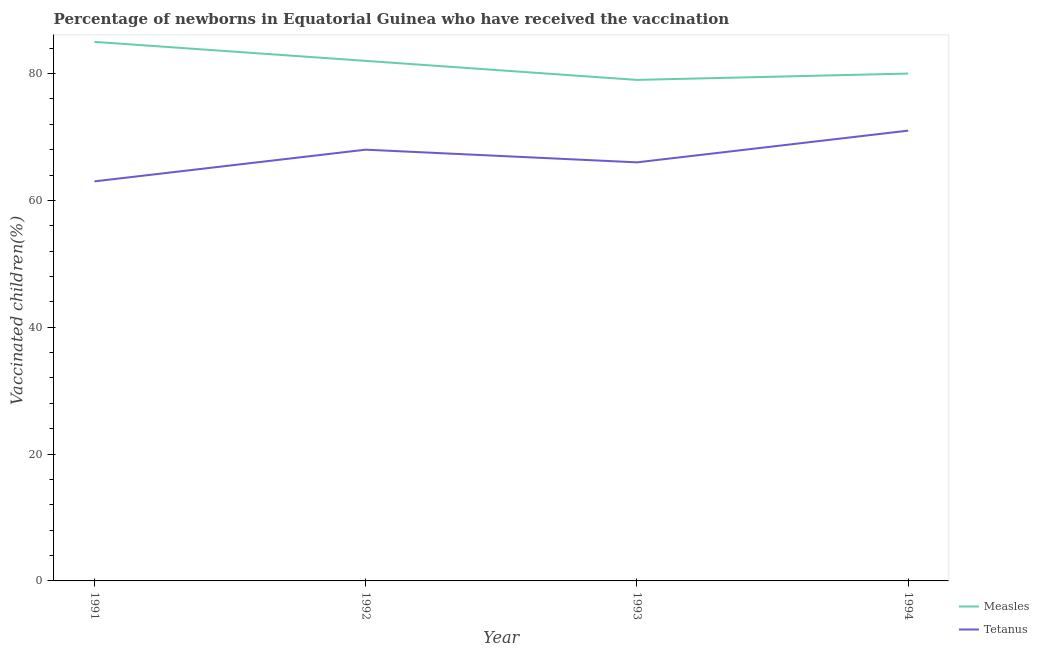What is the percentage of newborns who received vaccination for tetanus in 1992?
Provide a short and direct response. 68. Across all years, what is the maximum percentage of newborns who received vaccination for tetanus?
Give a very brief answer. 71. Across all years, what is the minimum percentage of newborns who received vaccination for tetanus?
Offer a terse response. 63. In which year was the percentage of newborns who received vaccination for measles maximum?
Your response must be concise. 1991. What is the total percentage of newborns who received vaccination for tetanus in the graph?
Ensure brevity in your answer.  268. What is the difference between the percentage of newborns who received vaccination for tetanus in 1993 and that in 1994?
Keep it short and to the point. -5. What is the difference between the percentage of newborns who received vaccination for tetanus in 1991 and the percentage of newborns who received vaccination for measles in 1992?
Your answer should be compact. -19. What is the average percentage of newborns who received vaccination for measles per year?
Your answer should be compact. 81.5. In the year 1994, what is the difference between the percentage of newborns who received vaccination for measles and percentage of newborns who received vaccination for tetanus?
Make the answer very short. 9. What is the ratio of the percentage of newborns who received vaccination for measles in 1991 to that in 1994?
Make the answer very short. 1.06. Is the percentage of newborns who received vaccination for measles in 1992 less than that in 1994?
Your response must be concise. No. What is the difference between the highest and the lowest percentage of newborns who received vaccination for tetanus?
Make the answer very short. 8. In how many years, is the percentage of newborns who received vaccination for tetanus greater than the average percentage of newborns who received vaccination for tetanus taken over all years?
Make the answer very short. 2. Is the percentage of newborns who received vaccination for measles strictly greater than the percentage of newborns who received vaccination for tetanus over the years?
Give a very brief answer. Yes. How many years are there in the graph?
Give a very brief answer. 4. Does the graph contain grids?
Provide a succinct answer. No. What is the title of the graph?
Your response must be concise. Percentage of newborns in Equatorial Guinea who have received the vaccination. What is the label or title of the Y-axis?
Ensure brevity in your answer.  Vaccinated children(%)
. What is the Vaccinated children(%)
 of Measles in 1992?
Offer a terse response. 82. What is the Vaccinated children(%)
 in Tetanus in 1992?
Your response must be concise. 68. What is the Vaccinated children(%)
 in Measles in 1993?
Provide a short and direct response. 79. What is the Vaccinated children(%)
 of Measles in 1994?
Keep it short and to the point. 80. What is the Vaccinated children(%)
 of Tetanus in 1994?
Provide a short and direct response. 71. Across all years, what is the maximum Vaccinated children(%)
 of Measles?
Ensure brevity in your answer.  85. Across all years, what is the maximum Vaccinated children(%)
 of Tetanus?
Your answer should be very brief. 71. Across all years, what is the minimum Vaccinated children(%)
 in Measles?
Offer a very short reply. 79. Across all years, what is the minimum Vaccinated children(%)
 in Tetanus?
Offer a terse response. 63. What is the total Vaccinated children(%)
 in Measles in the graph?
Provide a short and direct response. 326. What is the total Vaccinated children(%)
 of Tetanus in the graph?
Give a very brief answer. 268. What is the difference between the Vaccinated children(%)
 in Tetanus in 1991 and that in 1992?
Offer a very short reply. -5. What is the difference between the Vaccinated children(%)
 in Measles in 1991 and that in 1993?
Your answer should be very brief. 6. What is the difference between the Vaccinated children(%)
 in Measles in 1991 and that in 1994?
Your answer should be very brief. 5. What is the difference between the Vaccinated children(%)
 of Tetanus in 1991 and that in 1994?
Your response must be concise. -8. What is the difference between the Vaccinated children(%)
 in Tetanus in 1992 and that in 1993?
Your answer should be compact. 2. What is the difference between the Vaccinated children(%)
 of Measles in 1992 and that in 1994?
Offer a very short reply. 2. What is the difference between the Vaccinated children(%)
 of Tetanus in 1992 and that in 1994?
Your answer should be very brief. -3. What is the average Vaccinated children(%)
 in Measles per year?
Your answer should be compact. 81.5. What is the average Vaccinated children(%)
 of Tetanus per year?
Give a very brief answer. 67. In the year 1992, what is the difference between the Vaccinated children(%)
 of Measles and Vaccinated children(%)
 of Tetanus?
Offer a very short reply. 14. What is the ratio of the Vaccinated children(%)
 in Measles in 1991 to that in 1992?
Provide a short and direct response. 1.04. What is the ratio of the Vaccinated children(%)
 in Tetanus in 1991 to that in 1992?
Provide a short and direct response. 0.93. What is the ratio of the Vaccinated children(%)
 in Measles in 1991 to that in 1993?
Your answer should be very brief. 1.08. What is the ratio of the Vaccinated children(%)
 in Tetanus in 1991 to that in 1993?
Offer a terse response. 0.95. What is the ratio of the Vaccinated children(%)
 of Measles in 1991 to that in 1994?
Provide a succinct answer. 1.06. What is the ratio of the Vaccinated children(%)
 of Tetanus in 1991 to that in 1994?
Offer a very short reply. 0.89. What is the ratio of the Vaccinated children(%)
 of Measles in 1992 to that in 1993?
Make the answer very short. 1.04. What is the ratio of the Vaccinated children(%)
 in Tetanus in 1992 to that in 1993?
Provide a succinct answer. 1.03. What is the ratio of the Vaccinated children(%)
 in Tetanus in 1992 to that in 1994?
Provide a succinct answer. 0.96. What is the ratio of the Vaccinated children(%)
 in Measles in 1993 to that in 1994?
Offer a very short reply. 0.99. What is the ratio of the Vaccinated children(%)
 in Tetanus in 1993 to that in 1994?
Your answer should be compact. 0.93. What is the difference between the highest and the second highest Vaccinated children(%)
 of Measles?
Provide a succinct answer. 3. What is the difference between the highest and the second highest Vaccinated children(%)
 of Tetanus?
Provide a short and direct response. 3. 